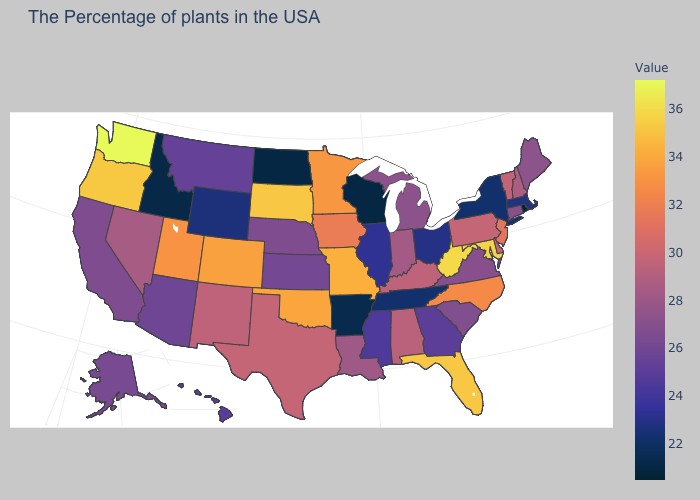Which states have the lowest value in the USA?
Give a very brief answer. Rhode Island. Does the map have missing data?
Give a very brief answer. No. Which states have the lowest value in the USA?
Short answer required. Rhode Island. 